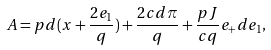Convert formula to latex. <formula><loc_0><loc_0><loc_500><loc_500>A = p d ( x + \frac { 2 e _ { 1 } } { q } ) + \frac { 2 c d \pi } { q } + \frac { p J } { c q } e _ { + } d e _ { 1 } ,</formula> 